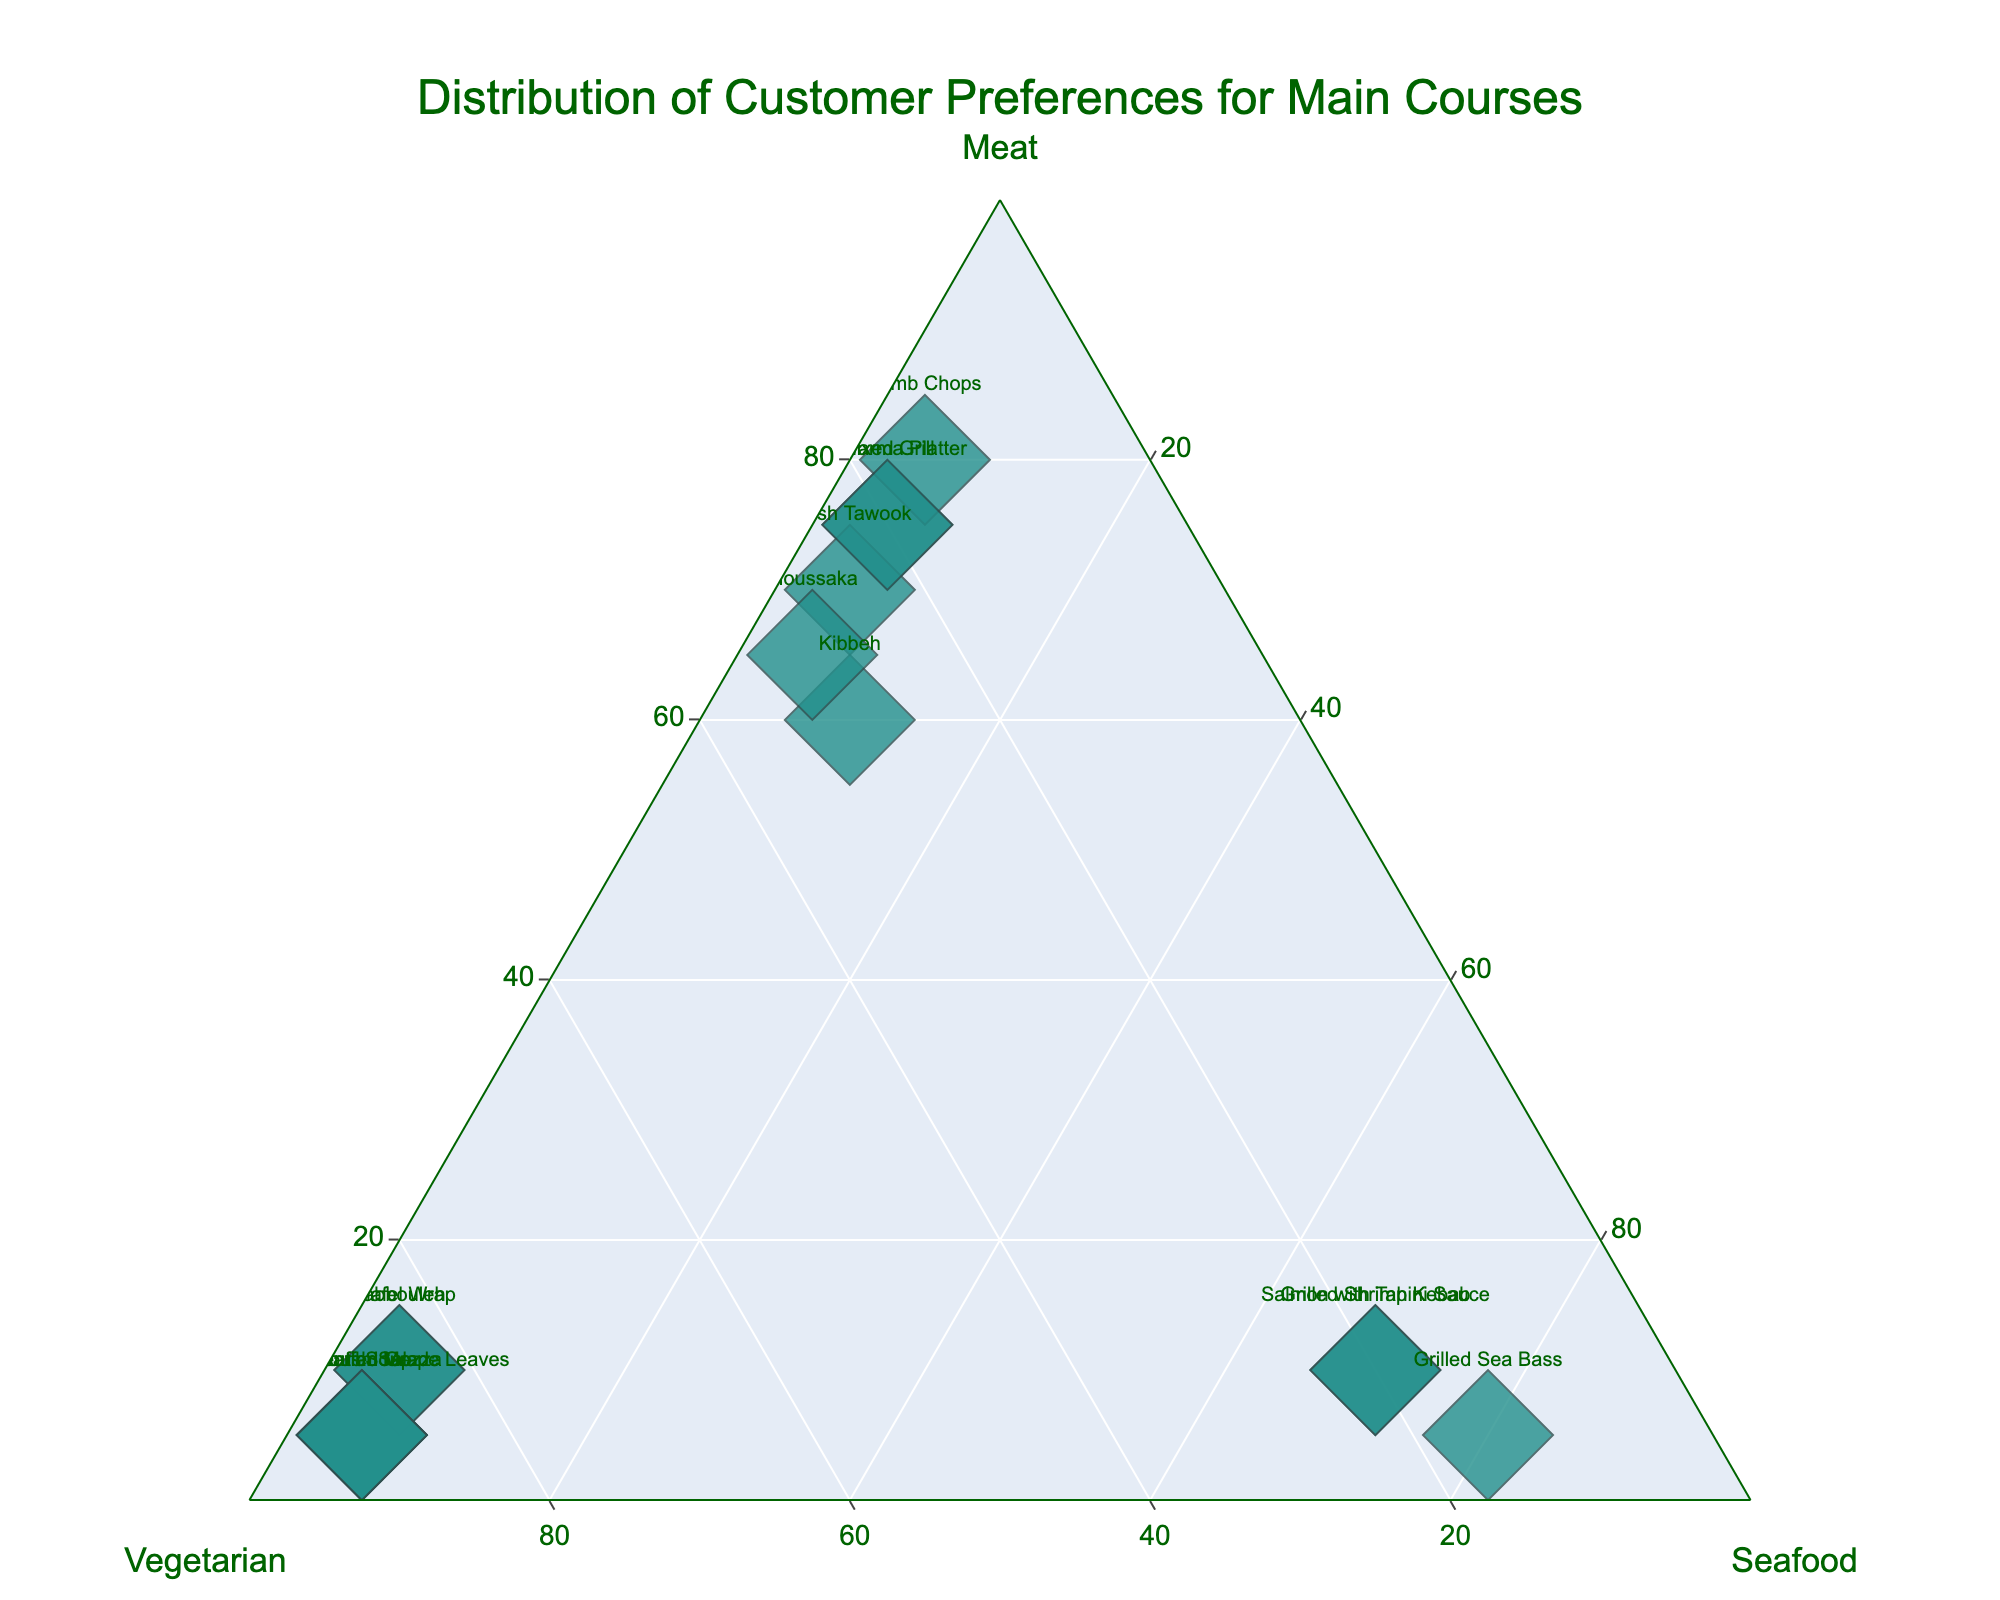Which dish has the highest meat preference? The position furthest along the axis labeled "Meat" and thus closest to the "Meat" vertex will represent the dish with the highest meat preference. In this case, the Shawarma Platter is positioned nearest to the meat apex.
Answer: Shawarma Platter How many dishes have a majority preference for seafood? A majority preference for seafood means the point would be closer to the seafood vertex. Observing the plot, two dishes (Grilled Sea Bass and Salmon with Tahini Sauce) fall into this category.
Answer: 2 Which dish has the smallest preference for vegetarian options? Look for the dish positioned furthest from the Vegetarian axis. Lamb Chops and Shish Tawook have the least preference for vegetarian options with a value of 15%.
Answer: Lamb Chops (Also Shish Tawook) What is the average percentage preference for vegetarian dishes across all presented dishes? Sum up the vegetarian percentages for all dishes and divide by the number of dishes: (30 + 85 + 15 + 20 + 90 + 25 + 85 + 15 + 90 + 20 + 30 + 90 + 20 + 90 + 20)/15 = 45%
Answer: 45% Which dish sees an equal preference for seafood and vegetarian options? Identify the dish where the percentages for both Seafood and Vegetarian are the same. None of the dishes have exactly equal percentages for these two categories, so the answer is none.
Answer: None How does the preference for seafood in Grilled Shrimp Kebab compare to Grilled Sea Bass? Compare the "Seafood" values for both dishes. Grilled Shrimp Kebab has a seafood preference of 70% while Grilled Sea Bass has a preference of 80%.
Answer: Grilled Sea Bass has a higher seafood preference Are there more vegetarian-preferred dishes or meat-preferred dishes? Count the number of dishes with a majority preference for Vegetarian (> 50%) versus those with a majority preference for Meat (> 50%). Vegetarian-preferred dishes are 5 (Tabbouleh, Vegetarian Mezza, Falafel Wrap, Fattoush Salad, Lentil Soup), and meat-preferred dishes are 6 (Kibbeh, Shawarma Platter, Shish Tawook, Lamb Chops, Moussaka, Mixed Grill).
Answer: More meat-preferred dishes What is the sum of preferences for Shawarma Platter across all categories? Add the Meat, Vegetarian, and Seafood preferences for Shawarma Platter: 75% + 20% + 5% = 100%.
Answer: 100% Which dish has an equal distribution of preferences across Meat, Vegetarian, and Seafood categories? A dish with an equal distribution would be positioned near the center of the ternary plot. No dish shows an equal distribution in the given dataset, closest equal distribution is not present.
Answer: None 